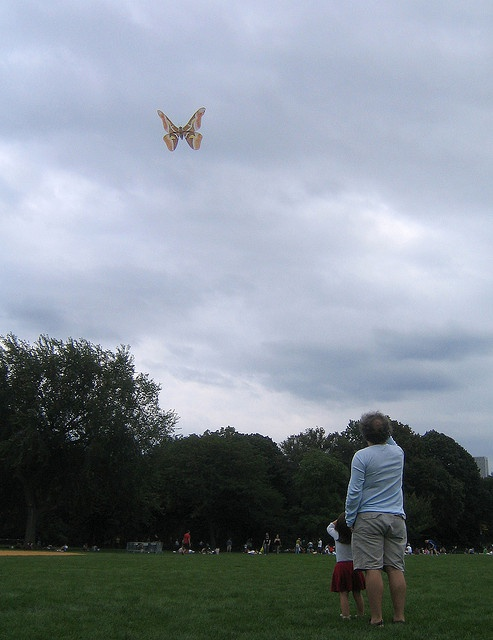Describe the objects in this image and their specific colors. I can see people in lightblue, gray, and black tones, people in lightblue, black, gray, and maroon tones, people in lightblue, black, gray, darkgreen, and navy tones, kite in lightblue, darkgray, and gray tones, and people in lightblue, black, maroon, and gray tones in this image. 